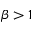<formula> <loc_0><loc_0><loc_500><loc_500>\beta > 1</formula> 